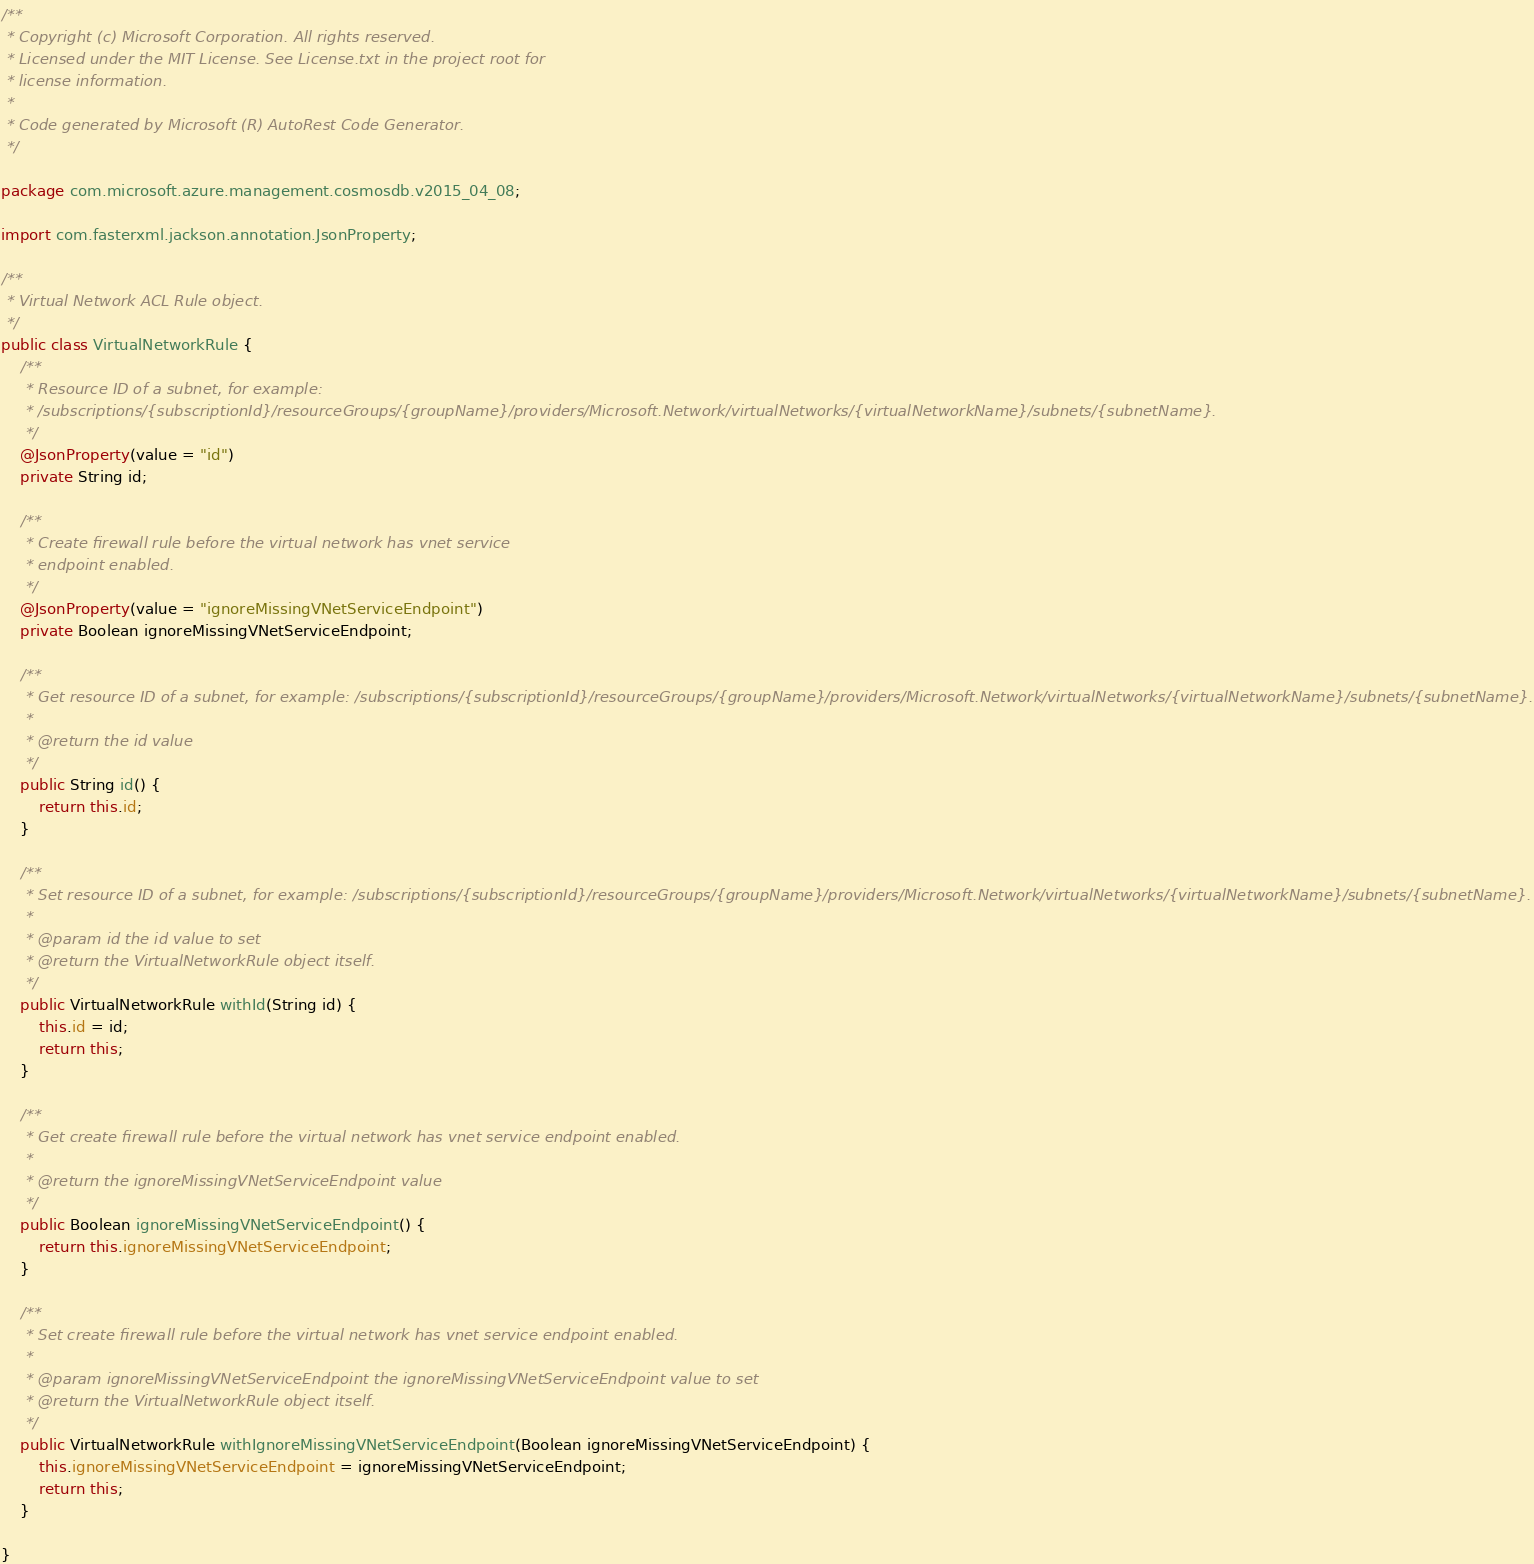<code> <loc_0><loc_0><loc_500><loc_500><_Java_>/**
 * Copyright (c) Microsoft Corporation. All rights reserved.
 * Licensed under the MIT License. See License.txt in the project root for
 * license information.
 *
 * Code generated by Microsoft (R) AutoRest Code Generator.
 */

package com.microsoft.azure.management.cosmosdb.v2015_04_08;

import com.fasterxml.jackson.annotation.JsonProperty;

/**
 * Virtual Network ACL Rule object.
 */
public class VirtualNetworkRule {
    /**
     * Resource ID of a subnet, for example:
     * /subscriptions/{subscriptionId}/resourceGroups/{groupName}/providers/Microsoft.Network/virtualNetworks/{virtualNetworkName}/subnets/{subnetName}.
     */
    @JsonProperty(value = "id")
    private String id;

    /**
     * Create firewall rule before the virtual network has vnet service
     * endpoint enabled.
     */
    @JsonProperty(value = "ignoreMissingVNetServiceEndpoint")
    private Boolean ignoreMissingVNetServiceEndpoint;

    /**
     * Get resource ID of a subnet, for example: /subscriptions/{subscriptionId}/resourceGroups/{groupName}/providers/Microsoft.Network/virtualNetworks/{virtualNetworkName}/subnets/{subnetName}.
     *
     * @return the id value
     */
    public String id() {
        return this.id;
    }

    /**
     * Set resource ID of a subnet, for example: /subscriptions/{subscriptionId}/resourceGroups/{groupName}/providers/Microsoft.Network/virtualNetworks/{virtualNetworkName}/subnets/{subnetName}.
     *
     * @param id the id value to set
     * @return the VirtualNetworkRule object itself.
     */
    public VirtualNetworkRule withId(String id) {
        this.id = id;
        return this;
    }

    /**
     * Get create firewall rule before the virtual network has vnet service endpoint enabled.
     *
     * @return the ignoreMissingVNetServiceEndpoint value
     */
    public Boolean ignoreMissingVNetServiceEndpoint() {
        return this.ignoreMissingVNetServiceEndpoint;
    }

    /**
     * Set create firewall rule before the virtual network has vnet service endpoint enabled.
     *
     * @param ignoreMissingVNetServiceEndpoint the ignoreMissingVNetServiceEndpoint value to set
     * @return the VirtualNetworkRule object itself.
     */
    public VirtualNetworkRule withIgnoreMissingVNetServiceEndpoint(Boolean ignoreMissingVNetServiceEndpoint) {
        this.ignoreMissingVNetServiceEndpoint = ignoreMissingVNetServiceEndpoint;
        return this;
    }

}
</code> 